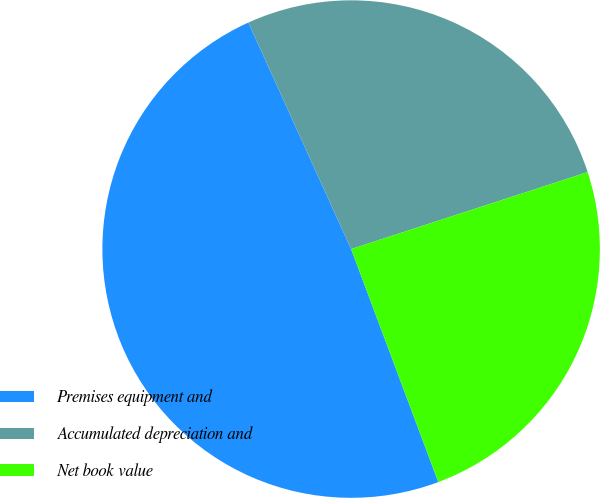<chart> <loc_0><loc_0><loc_500><loc_500><pie_chart><fcel>Premises equipment and<fcel>Accumulated depreciation and<fcel>Net book value<nl><fcel>48.92%<fcel>26.77%<fcel>24.31%<nl></chart> 